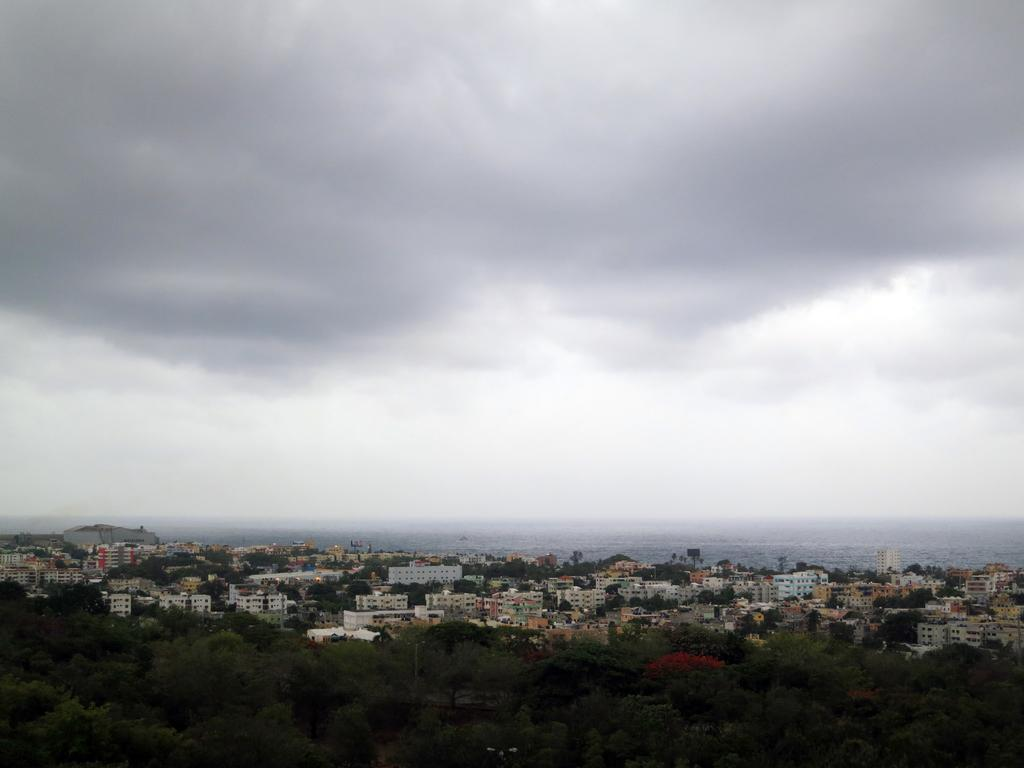What type of structures can be seen in the image? There are buildings in the image. What natural elements are present in the image? There are trees in the image. What man-made objects can be seen in the image? There are poles and towers in the image. What is the body of water visible in the image? There is water visible in the image. What can be seen in the sky at the top of the image? There are clouds in the sky at the top of the image. How many cars are parked near the river in the image? There is no river or cars present in the image. What type of wind can be seen blowing through the zephyr in the image? There is no zephyr or wind visible in the image. 